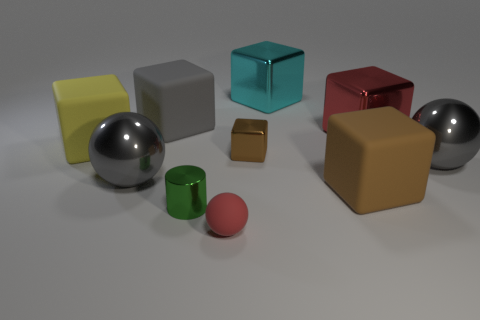Subtract all red spheres. How many spheres are left? 2 Subtract 0 blue blocks. How many objects are left? 10 Subtract all cylinders. How many objects are left? 9 Subtract 4 cubes. How many cubes are left? 2 Subtract all yellow cubes. Subtract all purple cylinders. How many cubes are left? 5 Subtract all cyan cylinders. How many brown blocks are left? 2 Subtract all small cubes. Subtract all tiny green objects. How many objects are left? 8 Add 5 brown blocks. How many brown blocks are left? 7 Add 1 yellow matte things. How many yellow matte things exist? 2 Subtract all red balls. How many balls are left? 2 